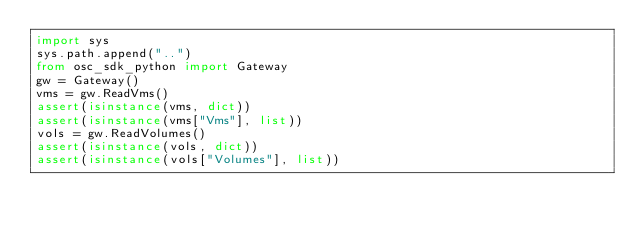Convert code to text. <code><loc_0><loc_0><loc_500><loc_500><_Python_>import sys
sys.path.append("..")
from osc_sdk_python import Gateway
gw = Gateway()
vms = gw.ReadVms()
assert(isinstance(vms, dict))
assert(isinstance(vms["Vms"], list))
vols = gw.ReadVolumes()
assert(isinstance(vols, dict))
assert(isinstance(vols["Volumes"], list))

</code> 